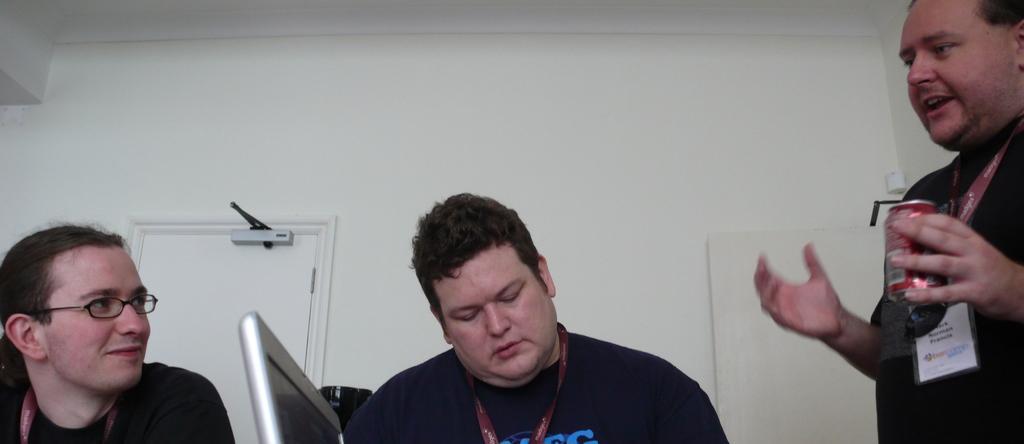How would you summarize this image in a sentence or two? In this image I can see three people with different color dresses. I can see these people are wearing the identification cards and one person holding the tin. In the background I can see the wall and the door. 